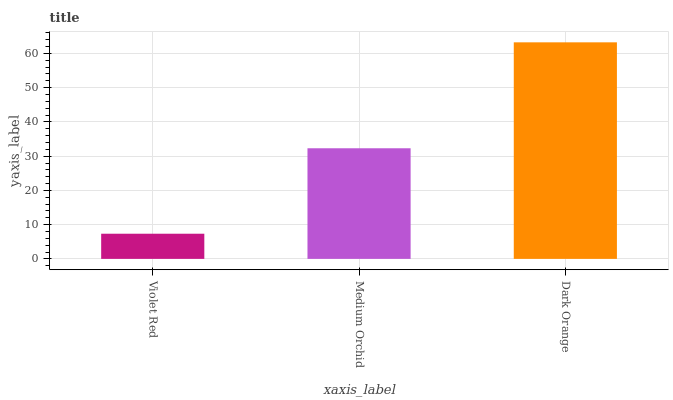Is Medium Orchid the minimum?
Answer yes or no. No. Is Medium Orchid the maximum?
Answer yes or no. No. Is Medium Orchid greater than Violet Red?
Answer yes or no. Yes. Is Violet Red less than Medium Orchid?
Answer yes or no. Yes. Is Violet Red greater than Medium Orchid?
Answer yes or no. No. Is Medium Orchid less than Violet Red?
Answer yes or no. No. Is Medium Orchid the high median?
Answer yes or no. Yes. Is Medium Orchid the low median?
Answer yes or no. Yes. Is Violet Red the high median?
Answer yes or no. No. Is Dark Orange the low median?
Answer yes or no. No. 